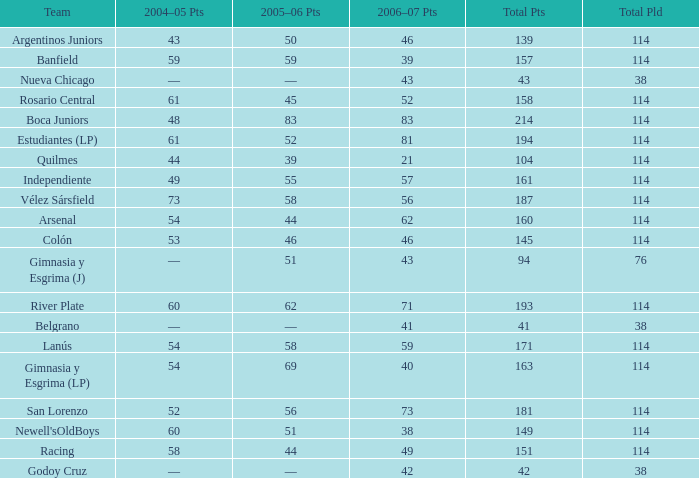What is the total number of points for a total pld less than 38? 0.0. 